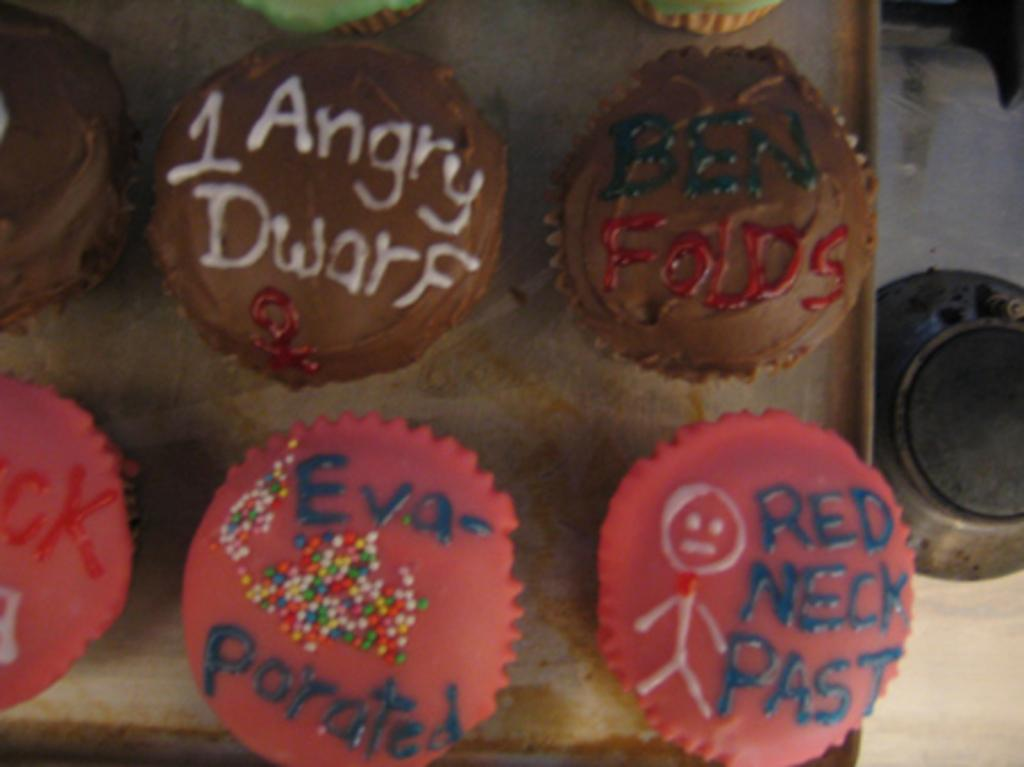What type of food is visible in the tray in the image? There are cupcakes in a tray in the image. Where is the tray with cupcakes located? The tray is placed on a table in the image. What other object can be seen on the floor in the image? There is a bowl on the floor in the image. What force is being applied to the cupcakes in the image? There is no force being applied to the cupcakes in the image; they are stationary in the tray. 